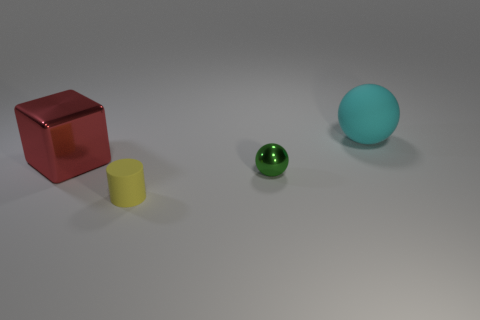Add 4 tiny green metallic objects. How many objects exist? 8 Subtract all blocks. How many objects are left? 3 Add 3 small green spheres. How many small green spheres exist? 4 Subtract 0 yellow cubes. How many objects are left? 4 Subtract all tiny green spheres. Subtract all tiny green balls. How many objects are left? 2 Add 1 cyan rubber spheres. How many cyan rubber spheres are left? 2 